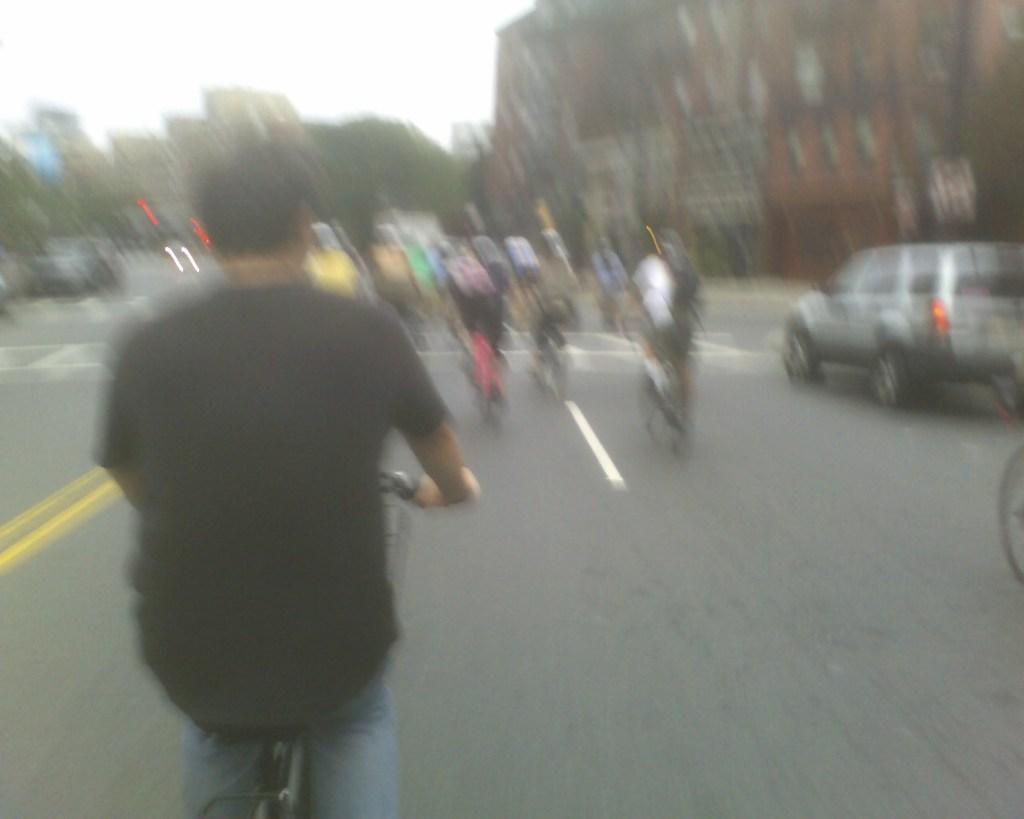What is the main feature of the image? There is a road in the image. What are the people on the road doing? There are people riding cycles on the road. Are there any other vehicles on the road besides cycles? Yes, there are vehicles on the road. What can be seen in the background of the image? There is a building in the background of the image. How would you describe the quality of the image? The image appears to be blurry. What type of copper or brass object can be seen joining the cycles together in the image? There is no copper or brass object present in the image, nor are the cycles joined together. 